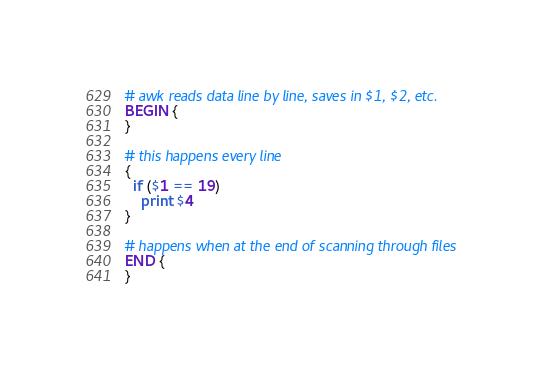Convert code to text. <code><loc_0><loc_0><loc_500><loc_500><_Awk_># awk reads data line by line, saves in $1, $2, etc.
BEGIN {
}

# this happens every line
{
  if ($1 == 19)
    print $4
}

# happens when at the end of scanning through files
END {
}
</code> 